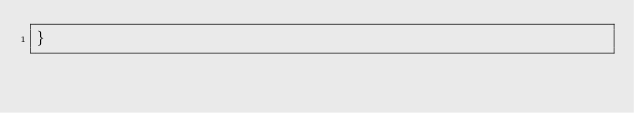Convert code to text. <code><loc_0><loc_0><loc_500><loc_500><_CSS_>}
</code> 